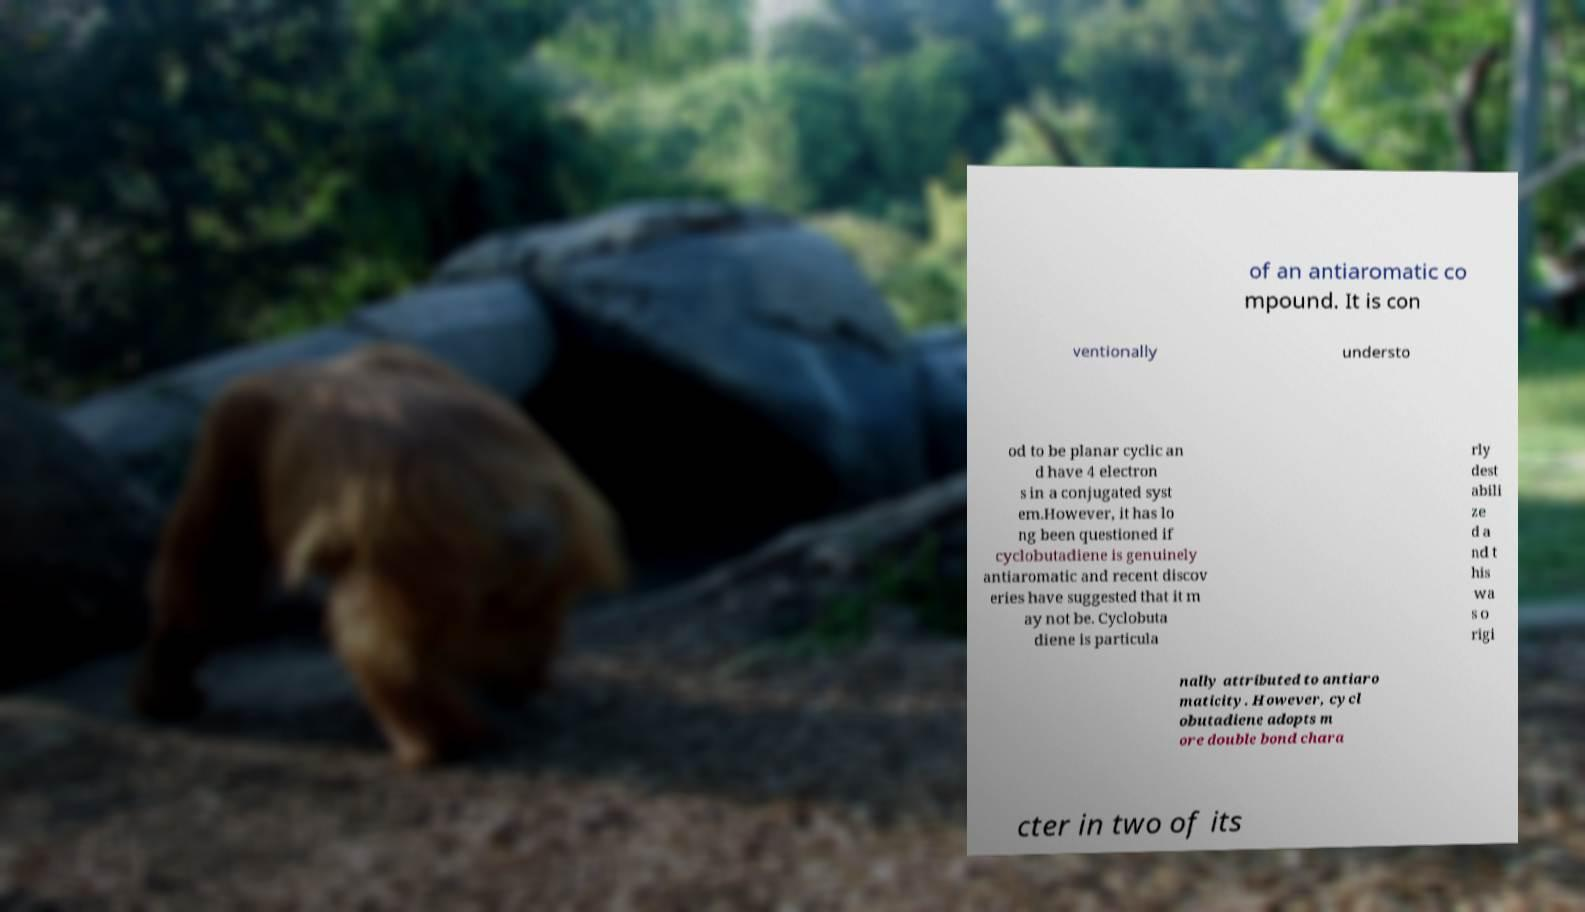Could you assist in decoding the text presented in this image and type it out clearly? of an antiaromatic co mpound. It is con ventionally understo od to be planar cyclic an d have 4 electron s in a conjugated syst em.However, it has lo ng been questioned if cyclobutadiene is genuinely antiaromatic and recent discov eries have suggested that it m ay not be. Cyclobuta diene is particula rly dest abili ze d a nd t his wa s o rigi nally attributed to antiaro maticity. However, cycl obutadiene adopts m ore double bond chara cter in two of its 